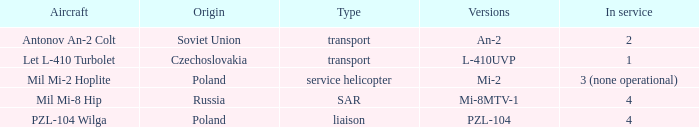Tell me the origin for mi-2 Poland. 